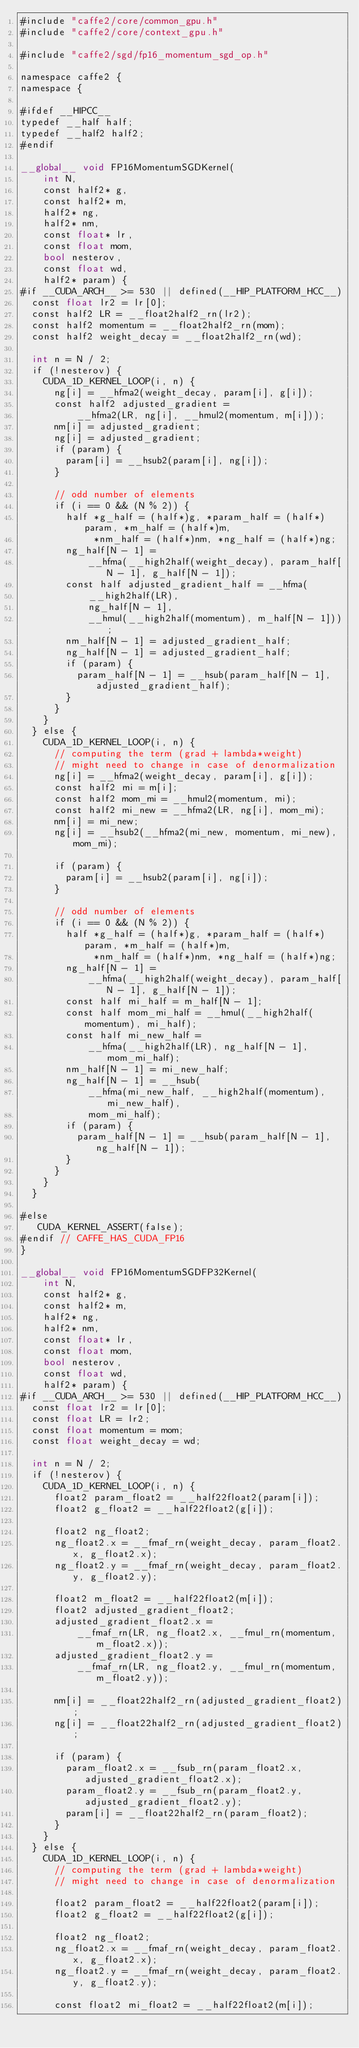<code> <loc_0><loc_0><loc_500><loc_500><_Cuda_>#include "caffe2/core/common_gpu.h"
#include "caffe2/core/context_gpu.h"

#include "caffe2/sgd/fp16_momentum_sgd_op.h"

namespace caffe2 {
namespace {

#ifdef __HIPCC__
typedef __half half;
typedef __half2 half2;
#endif

__global__ void FP16MomentumSGDKernel(
    int N,
    const half2* g,
    const half2* m,
    half2* ng,
    half2* nm,
    const float* lr,
    const float mom,
    bool nesterov,
    const float wd,
    half2* param) {
#if __CUDA_ARCH__ >= 530 || defined(__HIP_PLATFORM_HCC__)
  const float lr2 = lr[0];
  const half2 LR = __float2half2_rn(lr2);
  const half2 momentum = __float2half2_rn(mom);
  const half2 weight_decay = __float2half2_rn(wd);

  int n = N / 2;
  if (!nesterov) {
    CUDA_1D_KERNEL_LOOP(i, n) {
      ng[i] = __hfma2(weight_decay, param[i], g[i]);
      const half2 adjusted_gradient =
          __hfma2(LR, ng[i], __hmul2(momentum, m[i]));
      nm[i] = adjusted_gradient;
      ng[i] = adjusted_gradient;
      if (param) {
        param[i] = __hsub2(param[i], ng[i]);
      }

      // odd number of elements
      if (i == 0 && (N % 2)) {
        half *g_half = (half*)g, *param_half = (half*)param, *m_half = (half*)m,
             *nm_half = (half*)nm, *ng_half = (half*)ng;
        ng_half[N - 1] =
            __hfma(__high2half(weight_decay), param_half[N - 1], g_half[N - 1]);
        const half adjusted_gradient_half = __hfma(
            __high2half(LR),
            ng_half[N - 1],
            __hmul(__high2half(momentum), m_half[N - 1]));
        nm_half[N - 1] = adjusted_gradient_half;
        ng_half[N - 1] = adjusted_gradient_half;
        if (param) {
          param_half[N - 1] = __hsub(param_half[N - 1], adjusted_gradient_half);
        }
      }
    }
  } else {
    CUDA_1D_KERNEL_LOOP(i, n) {
      // computing the term (grad + lambda*weight)
      // might need to change in case of denormalization
      ng[i] = __hfma2(weight_decay, param[i], g[i]);
      const half2 mi = m[i];
      const half2 mom_mi = __hmul2(momentum, mi);
      const half2 mi_new = __hfma2(LR, ng[i], mom_mi);
      nm[i] = mi_new;
      ng[i] = __hsub2(__hfma2(mi_new, momentum, mi_new), mom_mi);

      if (param) {
        param[i] = __hsub2(param[i], ng[i]);
      }

      // odd number of elements
      if (i == 0 && (N % 2)) {
        half *g_half = (half*)g, *param_half = (half*)param, *m_half = (half*)m,
             *nm_half = (half*)nm, *ng_half = (half*)ng;
        ng_half[N - 1] =
            __hfma(__high2half(weight_decay), param_half[N - 1], g_half[N - 1]);
        const half mi_half = m_half[N - 1];
        const half mom_mi_half = __hmul(__high2half(momentum), mi_half);
        const half mi_new_half =
            __hfma(__high2half(LR), ng_half[N - 1], mom_mi_half);
        nm_half[N - 1] = mi_new_half;
        ng_half[N - 1] = __hsub(
            __hfma(mi_new_half, __high2half(momentum), mi_new_half),
            mom_mi_half);
        if (param) {
          param_half[N - 1] = __hsub(param_half[N - 1], ng_half[N - 1]);
        }
      }
    }
  }

#else
   CUDA_KERNEL_ASSERT(false);
#endif // CAFFE_HAS_CUDA_FP16
}

__global__ void FP16MomentumSGDFP32Kernel(
    int N,
    const half2* g,
    const half2* m,
    half2* ng,
    half2* nm,
    const float* lr,
    const float mom,
    bool nesterov,
    const float wd,
    half2* param) {
#if __CUDA_ARCH__ >= 530 || defined(__HIP_PLATFORM_HCC__)
  const float lr2 = lr[0];
  const float LR = lr2;
  const float momentum = mom;
  const float weight_decay = wd;

  int n = N / 2;
  if (!nesterov) {
    CUDA_1D_KERNEL_LOOP(i, n) {
      float2 param_float2 = __half22float2(param[i]);
      float2 g_float2 = __half22float2(g[i]);

      float2 ng_float2;
      ng_float2.x = __fmaf_rn(weight_decay, param_float2.x, g_float2.x);
      ng_float2.y = __fmaf_rn(weight_decay, param_float2.y, g_float2.y);

      float2 m_float2 = __half22float2(m[i]);
      float2 adjusted_gradient_float2;
      adjusted_gradient_float2.x =
          __fmaf_rn(LR, ng_float2.x, __fmul_rn(momentum, m_float2.x));
      adjusted_gradient_float2.y =
          __fmaf_rn(LR, ng_float2.y, __fmul_rn(momentum, m_float2.y));

      nm[i] = __float22half2_rn(adjusted_gradient_float2);
      ng[i] = __float22half2_rn(adjusted_gradient_float2);

      if (param) {
        param_float2.x = __fsub_rn(param_float2.x, adjusted_gradient_float2.x);
        param_float2.y = __fsub_rn(param_float2.y, adjusted_gradient_float2.y);
        param[i] = __float22half2_rn(param_float2);
      }
    }
  } else {
    CUDA_1D_KERNEL_LOOP(i, n) {
      // computing the term (grad + lambda*weight)
      // might need to change in case of denormalization

      float2 param_float2 = __half22float2(param[i]);
      float2 g_float2 = __half22float2(g[i]);

      float2 ng_float2;
      ng_float2.x = __fmaf_rn(weight_decay, param_float2.x, g_float2.x);
      ng_float2.y = __fmaf_rn(weight_decay, param_float2.y, g_float2.y);

      const float2 mi_float2 = __half22float2(m[i]);</code> 